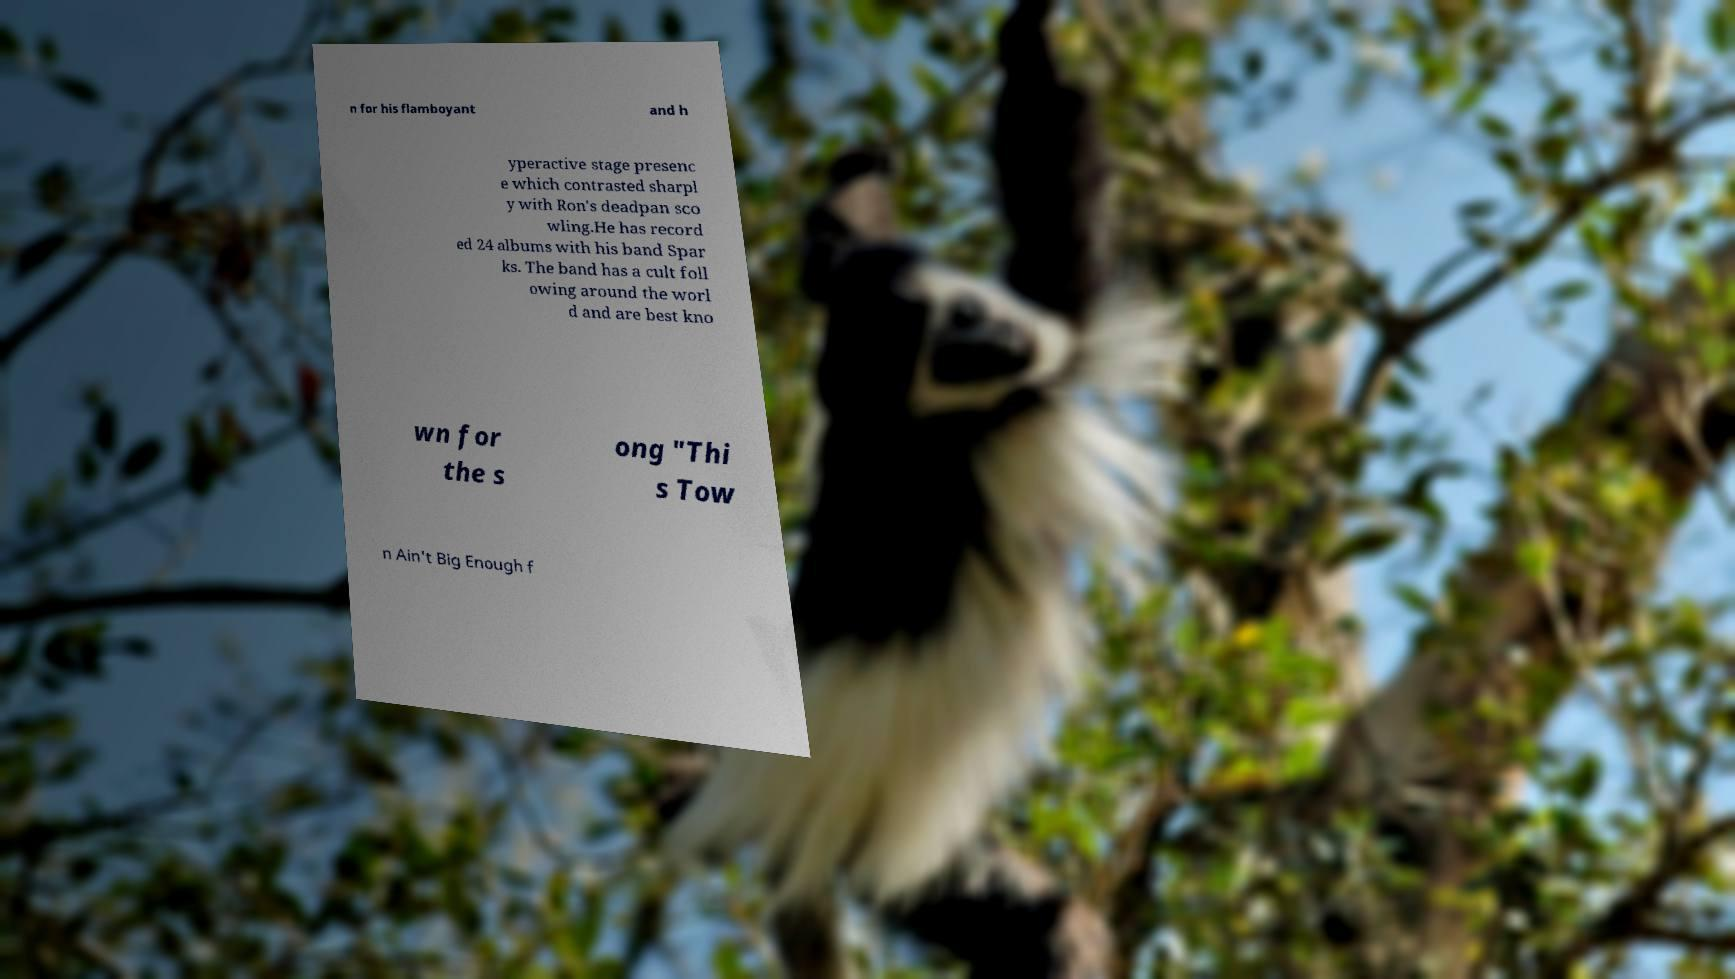For documentation purposes, I need the text within this image transcribed. Could you provide that? n for his flamboyant and h yperactive stage presenc e which contrasted sharpl y with Ron's deadpan sco wling.He has record ed 24 albums with his band Spar ks. The band has a cult foll owing around the worl d and are best kno wn for the s ong "Thi s Tow n Ain't Big Enough f 